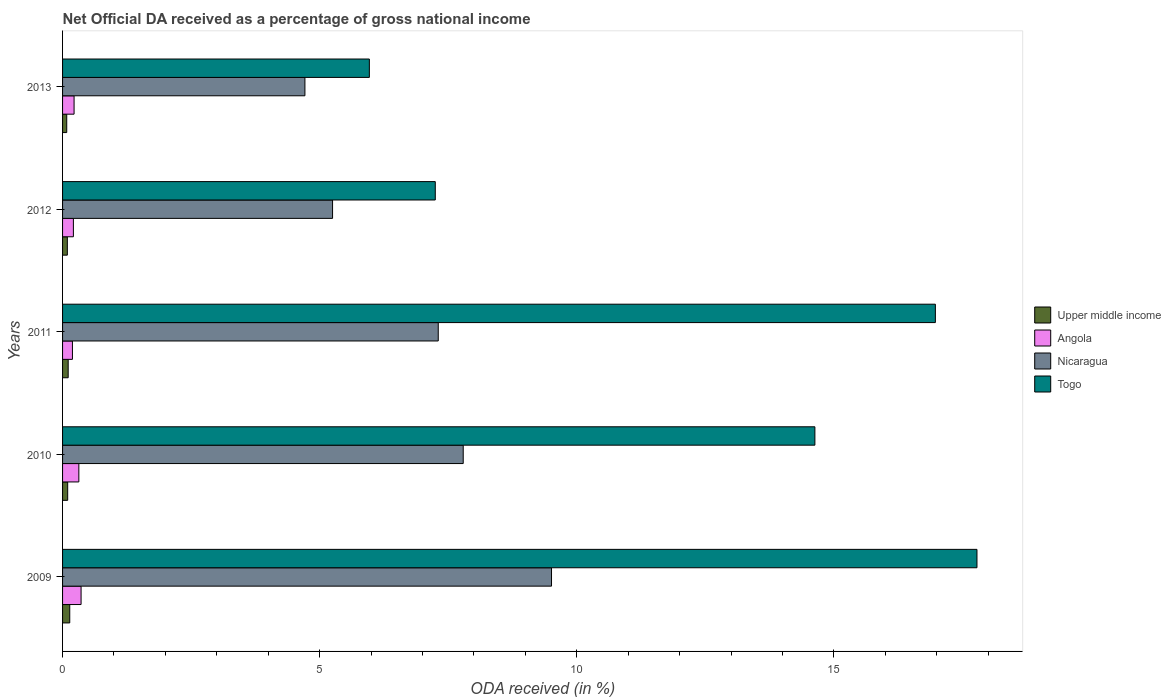How many different coloured bars are there?
Your answer should be compact. 4. Are the number of bars on each tick of the Y-axis equal?
Give a very brief answer. Yes. How many bars are there on the 1st tick from the top?
Your response must be concise. 4. What is the label of the 3rd group of bars from the top?
Offer a very short reply. 2011. In how many cases, is the number of bars for a given year not equal to the number of legend labels?
Your response must be concise. 0. What is the net official DA received in Togo in 2010?
Ensure brevity in your answer.  14.63. Across all years, what is the maximum net official DA received in Angola?
Keep it short and to the point. 0.36. Across all years, what is the minimum net official DA received in Togo?
Ensure brevity in your answer.  5.97. In which year was the net official DA received in Togo maximum?
Ensure brevity in your answer.  2009. What is the total net official DA received in Nicaragua in the graph?
Ensure brevity in your answer.  34.57. What is the difference between the net official DA received in Nicaragua in 2010 and that in 2013?
Your response must be concise. 3.08. What is the difference between the net official DA received in Togo in 2009 and the net official DA received in Nicaragua in 2012?
Provide a succinct answer. 12.53. What is the average net official DA received in Togo per year?
Your answer should be very brief. 12.52. In the year 2012, what is the difference between the net official DA received in Nicaragua and net official DA received in Togo?
Provide a succinct answer. -2. In how many years, is the net official DA received in Upper middle income greater than 13 %?
Your answer should be very brief. 0. What is the ratio of the net official DA received in Togo in 2009 to that in 2010?
Give a very brief answer. 1.22. Is the net official DA received in Upper middle income in 2010 less than that in 2013?
Your response must be concise. No. What is the difference between the highest and the second highest net official DA received in Upper middle income?
Make the answer very short. 0.03. What is the difference between the highest and the lowest net official DA received in Nicaragua?
Your answer should be compact. 4.8. In how many years, is the net official DA received in Nicaragua greater than the average net official DA received in Nicaragua taken over all years?
Ensure brevity in your answer.  3. Is the sum of the net official DA received in Togo in 2011 and 2012 greater than the maximum net official DA received in Upper middle income across all years?
Provide a short and direct response. Yes. What does the 3rd bar from the top in 2013 represents?
Ensure brevity in your answer.  Angola. What does the 3rd bar from the bottom in 2010 represents?
Offer a terse response. Nicaragua. Is it the case that in every year, the sum of the net official DA received in Nicaragua and net official DA received in Upper middle income is greater than the net official DA received in Angola?
Keep it short and to the point. Yes. How many years are there in the graph?
Your answer should be compact. 5. What is the difference between two consecutive major ticks on the X-axis?
Offer a very short reply. 5. Does the graph contain grids?
Offer a very short reply. No. What is the title of the graph?
Ensure brevity in your answer.  Net Official DA received as a percentage of gross national income. What is the label or title of the X-axis?
Make the answer very short. ODA received (in %). What is the label or title of the Y-axis?
Offer a very short reply. Years. What is the ODA received (in %) of Upper middle income in 2009?
Provide a succinct answer. 0.14. What is the ODA received (in %) in Angola in 2009?
Offer a very short reply. 0.36. What is the ODA received (in %) in Nicaragua in 2009?
Your response must be concise. 9.51. What is the ODA received (in %) of Togo in 2009?
Your answer should be very brief. 17.78. What is the ODA received (in %) of Upper middle income in 2010?
Make the answer very short. 0.1. What is the ODA received (in %) of Angola in 2010?
Your response must be concise. 0.32. What is the ODA received (in %) in Nicaragua in 2010?
Provide a short and direct response. 7.79. What is the ODA received (in %) of Togo in 2010?
Provide a succinct answer. 14.63. What is the ODA received (in %) of Upper middle income in 2011?
Offer a terse response. 0.11. What is the ODA received (in %) of Angola in 2011?
Your response must be concise. 0.19. What is the ODA received (in %) in Nicaragua in 2011?
Provide a short and direct response. 7.31. What is the ODA received (in %) in Togo in 2011?
Offer a very short reply. 16.97. What is the ODA received (in %) of Upper middle income in 2012?
Your answer should be very brief. 0.09. What is the ODA received (in %) in Angola in 2012?
Make the answer very short. 0.21. What is the ODA received (in %) in Nicaragua in 2012?
Ensure brevity in your answer.  5.25. What is the ODA received (in %) of Togo in 2012?
Your answer should be compact. 7.25. What is the ODA received (in %) of Upper middle income in 2013?
Your answer should be compact. 0.08. What is the ODA received (in %) in Angola in 2013?
Give a very brief answer. 0.22. What is the ODA received (in %) of Nicaragua in 2013?
Offer a terse response. 4.71. What is the ODA received (in %) in Togo in 2013?
Keep it short and to the point. 5.97. Across all years, what is the maximum ODA received (in %) in Upper middle income?
Your answer should be compact. 0.14. Across all years, what is the maximum ODA received (in %) of Angola?
Your response must be concise. 0.36. Across all years, what is the maximum ODA received (in %) of Nicaragua?
Make the answer very short. 9.51. Across all years, what is the maximum ODA received (in %) in Togo?
Offer a terse response. 17.78. Across all years, what is the minimum ODA received (in %) of Upper middle income?
Provide a short and direct response. 0.08. Across all years, what is the minimum ODA received (in %) of Angola?
Make the answer very short. 0.19. Across all years, what is the minimum ODA received (in %) of Nicaragua?
Offer a very short reply. 4.71. Across all years, what is the minimum ODA received (in %) in Togo?
Ensure brevity in your answer.  5.97. What is the total ODA received (in %) of Upper middle income in the graph?
Make the answer very short. 0.52. What is the total ODA received (in %) in Angola in the graph?
Your answer should be very brief. 1.3. What is the total ODA received (in %) in Nicaragua in the graph?
Offer a very short reply. 34.57. What is the total ODA received (in %) of Togo in the graph?
Provide a succinct answer. 62.6. What is the difference between the ODA received (in %) of Angola in 2009 and that in 2010?
Give a very brief answer. 0.04. What is the difference between the ODA received (in %) in Nicaragua in 2009 and that in 2010?
Keep it short and to the point. 1.72. What is the difference between the ODA received (in %) of Togo in 2009 and that in 2010?
Give a very brief answer. 3.15. What is the difference between the ODA received (in %) of Upper middle income in 2009 and that in 2011?
Provide a succinct answer. 0.03. What is the difference between the ODA received (in %) of Angola in 2009 and that in 2011?
Provide a succinct answer. 0.17. What is the difference between the ODA received (in %) of Nicaragua in 2009 and that in 2011?
Provide a succinct answer. 2.2. What is the difference between the ODA received (in %) of Togo in 2009 and that in 2011?
Give a very brief answer. 0.81. What is the difference between the ODA received (in %) in Upper middle income in 2009 and that in 2012?
Keep it short and to the point. 0.05. What is the difference between the ODA received (in %) in Angola in 2009 and that in 2012?
Offer a terse response. 0.15. What is the difference between the ODA received (in %) of Nicaragua in 2009 and that in 2012?
Your response must be concise. 4.26. What is the difference between the ODA received (in %) in Togo in 2009 and that in 2012?
Ensure brevity in your answer.  10.53. What is the difference between the ODA received (in %) of Upper middle income in 2009 and that in 2013?
Keep it short and to the point. 0.06. What is the difference between the ODA received (in %) of Angola in 2009 and that in 2013?
Provide a succinct answer. 0.14. What is the difference between the ODA received (in %) of Nicaragua in 2009 and that in 2013?
Make the answer very short. 4.8. What is the difference between the ODA received (in %) in Togo in 2009 and that in 2013?
Your answer should be very brief. 11.82. What is the difference between the ODA received (in %) of Upper middle income in 2010 and that in 2011?
Your answer should be very brief. -0.01. What is the difference between the ODA received (in %) of Angola in 2010 and that in 2011?
Provide a short and direct response. 0.12. What is the difference between the ODA received (in %) of Nicaragua in 2010 and that in 2011?
Your answer should be very brief. 0.49. What is the difference between the ODA received (in %) in Togo in 2010 and that in 2011?
Provide a succinct answer. -2.34. What is the difference between the ODA received (in %) in Upper middle income in 2010 and that in 2012?
Your answer should be very brief. 0.01. What is the difference between the ODA received (in %) of Angola in 2010 and that in 2012?
Your response must be concise. 0.11. What is the difference between the ODA received (in %) in Nicaragua in 2010 and that in 2012?
Offer a terse response. 2.54. What is the difference between the ODA received (in %) of Togo in 2010 and that in 2012?
Make the answer very short. 7.38. What is the difference between the ODA received (in %) in Upper middle income in 2010 and that in 2013?
Offer a terse response. 0.02. What is the difference between the ODA received (in %) of Angola in 2010 and that in 2013?
Offer a terse response. 0.09. What is the difference between the ODA received (in %) in Nicaragua in 2010 and that in 2013?
Your answer should be very brief. 3.08. What is the difference between the ODA received (in %) of Togo in 2010 and that in 2013?
Provide a succinct answer. 8.66. What is the difference between the ODA received (in %) in Upper middle income in 2011 and that in 2012?
Offer a terse response. 0.02. What is the difference between the ODA received (in %) in Angola in 2011 and that in 2012?
Your answer should be very brief. -0.02. What is the difference between the ODA received (in %) of Nicaragua in 2011 and that in 2012?
Give a very brief answer. 2.06. What is the difference between the ODA received (in %) of Togo in 2011 and that in 2012?
Make the answer very short. 9.73. What is the difference between the ODA received (in %) in Upper middle income in 2011 and that in 2013?
Offer a very short reply. 0.03. What is the difference between the ODA received (in %) of Angola in 2011 and that in 2013?
Give a very brief answer. -0.03. What is the difference between the ODA received (in %) in Nicaragua in 2011 and that in 2013?
Keep it short and to the point. 2.59. What is the difference between the ODA received (in %) in Togo in 2011 and that in 2013?
Your answer should be very brief. 11.01. What is the difference between the ODA received (in %) of Upper middle income in 2012 and that in 2013?
Give a very brief answer. 0.01. What is the difference between the ODA received (in %) in Angola in 2012 and that in 2013?
Offer a very short reply. -0.01. What is the difference between the ODA received (in %) in Nicaragua in 2012 and that in 2013?
Offer a terse response. 0.54. What is the difference between the ODA received (in %) in Togo in 2012 and that in 2013?
Your response must be concise. 1.28. What is the difference between the ODA received (in %) in Upper middle income in 2009 and the ODA received (in %) in Angola in 2010?
Keep it short and to the point. -0.18. What is the difference between the ODA received (in %) of Upper middle income in 2009 and the ODA received (in %) of Nicaragua in 2010?
Offer a very short reply. -7.65. What is the difference between the ODA received (in %) of Upper middle income in 2009 and the ODA received (in %) of Togo in 2010?
Provide a succinct answer. -14.49. What is the difference between the ODA received (in %) of Angola in 2009 and the ODA received (in %) of Nicaragua in 2010?
Your response must be concise. -7.43. What is the difference between the ODA received (in %) in Angola in 2009 and the ODA received (in %) in Togo in 2010?
Your answer should be very brief. -14.27. What is the difference between the ODA received (in %) in Nicaragua in 2009 and the ODA received (in %) in Togo in 2010?
Your answer should be very brief. -5.12. What is the difference between the ODA received (in %) of Upper middle income in 2009 and the ODA received (in %) of Angola in 2011?
Give a very brief answer. -0.05. What is the difference between the ODA received (in %) of Upper middle income in 2009 and the ODA received (in %) of Nicaragua in 2011?
Your response must be concise. -7.17. What is the difference between the ODA received (in %) in Upper middle income in 2009 and the ODA received (in %) in Togo in 2011?
Your response must be concise. -16.83. What is the difference between the ODA received (in %) of Angola in 2009 and the ODA received (in %) of Nicaragua in 2011?
Your answer should be very brief. -6.95. What is the difference between the ODA received (in %) in Angola in 2009 and the ODA received (in %) in Togo in 2011?
Make the answer very short. -16.61. What is the difference between the ODA received (in %) of Nicaragua in 2009 and the ODA received (in %) of Togo in 2011?
Keep it short and to the point. -7.46. What is the difference between the ODA received (in %) of Upper middle income in 2009 and the ODA received (in %) of Angola in 2012?
Keep it short and to the point. -0.07. What is the difference between the ODA received (in %) of Upper middle income in 2009 and the ODA received (in %) of Nicaragua in 2012?
Provide a short and direct response. -5.11. What is the difference between the ODA received (in %) of Upper middle income in 2009 and the ODA received (in %) of Togo in 2012?
Your answer should be compact. -7.11. What is the difference between the ODA received (in %) in Angola in 2009 and the ODA received (in %) in Nicaragua in 2012?
Provide a short and direct response. -4.89. What is the difference between the ODA received (in %) of Angola in 2009 and the ODA received (in %) of Togo in 2012?
Offer a terse response. -6.89. What is the difference between the ODA received (in %) of Nicaragua in 2009 and the ODA received (in %) of Togo in 2012?
Your answer should be very brief. 2.26. What is the difference between the ODA received (in %) in Upper middle income in 2009 and the ODA received (in %) in Angola in 2013?
Keep it short and to the point. -0.08. What is the difference between the ODA received (in %) of Upper middle income in 2009 and the ODA received (in %) of Nicaragua in 2013?
Your answer should be compact. -4.57. What is the difference between the ODA received (in %) in Upper middle income in 2009 and the ODA received (in %) in Togo in 2013?
Offer a terse response. -5.83. What is the difference between the ODA received (in %) in Angola in 2009 and the ODA received (in %) in Nicaragua in 2013?
Offer a terse response. -4.35. What is the difference between the ODA received (in %) of Angola in 2009 and the ODA received (in %) of Togo in 2013?
Make the answer very short. -5.61. What is the difference between the ODA received (in %) of Nicaragua in 2009 and the ODA received (in %) of Togo in 2013?
Provide a succinct answer. 3.54. What is the difference between the ODA received (in %) in Upper middle income in 2010 and the ODA received (in %) in Angola in 2011?
Provide a succinct answer. -0.09. What is the difference between the ODA received (in %) in Upper middle income in 2010 and the ODA received (in %) in Nicaragua in 2011?
Ensure brevity in your answer.  -7.21. What is the difference between the ODA received (in %) of Upper middle income in 2010 and the ODA received (in %) of Togo in 2011?
Ensure brevity in your answer.  -16.87. What is the difference between the ODA received (in %) in Angola in 2010 and the ODA received (in %) in Nicaragua in 2011?
Keep it short and to the point. -6.99. What is the difference between the ODA received (in %) of Angola in 2010 and the ODA received (in %) of Togo in 2011?
Give a very brief answer. -16.66. What is the difference between the ODA received (in %) of Nicaragua in 2010 and the ODA received (in %) of Togo in 2011?
Make the answer very short. -9.18. What is the difference between the ODA received (in %) of Upper middle income in 2010 and the ODA received (in %) of Angola in 2012?
Make the answer very short. -0.11. What is the difference between the ODA received (in %) in Upper middle income in 2010 and the ODA received (in %) in Nicaragua in 2012?
Your answer should be compact. -5.15. What is the difference between the ODA received (in %) in Upper middle income in 2010 and the ODA received (in %) in Togo in 2012?
Your answer should be compact. -7.15. What is the difference between the ODA received (in %) of Angola in 2010 and the ODA received (in %) of Nicaragua in 2012?
Offer a very short reply. -4.93. What is the difference between the ODA received (in %) in Angola in 2010 and the ODA received (in %) in Togo in 2012?
Give a very brief answer. -6.93. What is the difference between the ODA received (in %) in Nicaragua in 2010 and the ODA received (in %) in Togo in 2012?
Your answer should be compact. 0.54. What is the difference between the ODA received (in %) of Upper middle income in 2010 and the ODA received (in %) of Angola in 2013?
Keep it short and to the point. -0.12. What is the difference between the ODA received (in %) of Upper middle income in 2010 and the ODA received (in %) of Nicaragua in 2013?
Your answer should be compact. -4.61. What is the difference between the ODA received (in %) of Upper middle income in 2010 and the ODA received (in %) of Togo in 2013?
Your answer should be compact. -5.87. What is the difference between the ODA received (in %) in Angola in 2010 and the ODA received (in %) in Nicaragua in 2013?
Your response must be concise. -4.4. What is the difference between the ODA received (in %) of Angola in 2010 and the ODA received (in %) of Togo in 2013?
Make the answer very short. -5.65. What is the difference between the ODA received (in %) in Nicaragua in 2010 and the ODA received (in %) in Togo in 2013?
Give a very brief answer. 1.83. What is the difference between the ODA received (in %) of Upper middle income in 2011 and the ODA received (in %) of Angola in 2012?
Offer a very short reply. -0.1. What is the difference between the ODA received (in %) in Upper middle income in 2011 and the ODA received (in %) in Nicaragua in 2012?
Give a very brief answer. -5.14. What is the difference between the ODA received (in %) of Upper middle income in 2011 and the ODA received (in %) of Togo in 2012?
Offer a terse response. -7.14. What is the difference between the ODA received (in %) of Angola in 2011 and the ODA received (in %) of Nicaragua in 2012?
Provide a short and direct response. -5.06. What is the difference between the ODA received (in %) of Angola in 2011 and the ODA received (in %) of Togo in 2012?
Your response must be concise. -7.06. What is the difference between the ODA received (in %) in Nicaragua in 2011 and the ODA received (in %) in Togo in 2012?
Keep it short and to the point. 0.06. What is the difference between the ODA received (in %) of Upper middle income in 2011 and the ODA received (in %) of Angola in 2013?
Give a very brief answer. -0.11. What is the difference between the ODA received (in %) of Upper middle income in 2011 and the ODA received (in %) of Nicaragua in 2013?
Your answer should be very brief. -4.6. What is the difference between the ODA received (in %) of Upper middle income in 2011 and the ODA received (in %) of Togo in 2013?
Your response must be concise. -5.86. What is the difference between the ODA received (in %) of Angola in 2011 and the ODA received (in %) of Nicaragua in 2013?
Your response must be concise. -4.52. What is the difference between the ODA received (in %) of Angola in 2011 and the ODA received (in %) of Togo in 2013?
Your answer should be very brief. -5.77. What is the difference between the ODA received (in %) in Nicaragua in 2011 and the ODA received (in %) in Togo in 2013?
Provide a succinct answer. 1.34. What is the difference between the ODA received (in %) of Upper middle income in 2012 and the ODA received (in %) of Angola in 2013?
Your answer should be very brief. -0.13. What is the difference between the ODA received (in %) in Upper middle income in 2012 and the ODA received (in %) in Nicaragua in 2013?
Your answer should be very brief. -4.62. What is the difference between the ODA received (in %) of Upper middle income in 2012 and the ODA received (in %) of Togo in 2013?
Offer a very short reply. -5.87. What is the difference between the ODA received (in %) of Angola in 2012 and the ODA received (in %) of Nicaragua in 2013?
Your answer should be compact. -4.5. What is the difference between the ODA received (in %) of Angola in 2012 and the ODA received (in %) of Togo in 2013?
Give a very brief answer. -5.76. What is the difference between the ODA received (in %) of Nicaragua in 2012 and the ODA received (in %) of Togo in 2013?
Your response must be concise. -0.72. What is the average ODA received (in %) of Upper middle income per year?
Give a very brief answer. 0.1. What is the average ODA received (in %) of Angola per year?
Give a very brief answer. 0.26. What is the average ODA received (in %) of Nicaragua per year?
Your answer should be compact. 6.91. What is the average ODA received (in %) in Togo per year?
Keep it short and to the point. 12.52. In the year 2009, what is the difference between the ODA received (in %) of Upper middle income and ODA received (in %) of Angola?
Keep it short and to the point. -0.22. In the year 2009, what is the difference between the ODA received (in %) of Upper middle income and ODA received (in %) of Nicaragua?
Ensure brevity in your answer.  -9.37. In the year 2009, what is the difference between the ODA received (in %) of Upper middle income and ODA received (in %) of Togo?
Give a very brief answer. -17.64. In the year 2009, what is the difference between the ODA received (in %) in Angola and ODA received (in %) in Nicaragua?
Your response must be concise. -9.15. In the year 2009, what is the difference between the ODA received (in %) of Angola and ODA received (in %) of Togo?
Give a very brief answer. -17.42. In the year 2009, what is the difference between the ODA received (in %) in Nicaragua and ODA received (in %) in Togo?
Provide a succinct answer. -8.27. In the year 2010, what is the difference between the ODA received (in %) in Upper middle income and ODA received (in %) in Angola?
Offer a very short reply. -0.22. In the year 2010, what is the difference between the ODA received (in %) of Upper middle income and ODA received (in %) of Nicaragua?
Ensure brevity in your answer.  -7.69. In the year 2010, what is the difference between the ODA received (in %) of Upper middle income and ODA received (in %) of Togo?
Keep it short and to the point. -14.53. In the year 2010, what is the difference between the ODA received (in %) in Angola and ODA received (in %) in Nicaragua?
Make the answer very short. -7.48. In the year 2010, what is the difference between the ODA received (in %) in Angola and ODA received (in %) in Togo?
Provide a succinct answer. -14.31. In the year 2010, what is the difference between the ODA received (in %) in Nicaragua and ODA received (in %) in Togo?
Provide a short and direct response. -6.84. In the year 2011, what is the difference between the ODA received (in %) in Upper middle income and ODA received (in %) in Angola?
Provide a short and direct response. -0.08. In the year 2011, what is the difference between the ODA received (in %) of Upper middle income and ODA received (in %) of Nicaragua?
Your response must be concise. -7.2. In the year 2011, what is the difference between the ODA received (in %) in Upper middle income and ODA received (in %) in Togo?
Your answer should be very brief. -16.86. In the year 2011, what is the difference between the ODA received (in %) of Angola and ODA received (in %) of Nicaragua?
Provide a succinct answer. -7.11. In the year 2011, what is the difference between the ODA received (in %) of Angola and ODA received (in %) of Togo?
Your answer should be very brief. -16.78. In the year 2011, what is the difference between the ODA received (in %) in Nicaragua and ODA received (in %) in Togo?
Provide a succinct answer. -9.67. In the year 2012, what is the difference between the ODA received (in %) in Upper middle income and ODA received (in %) in Angola?
Your answer should be very brief. -0.12. In the year 2012, what is the difference between the ODA received (in %) of Upper middle income and ODA received (in %) of Nicaragua?
Ensure brevity in your answer.  -5.16. In the year 2012, what is the difference between the ODA received (in %) of Upper middle income and ODA received (in %) of Togo?
Ensure brevity in your answer.  -7.16. In the year 2012, what is the difference between the ODA received (in %) of Angola and ODA received (in %) of Nicaragua?
Offer a terse response. -5.04. In the year 2012, what is the difference between the ODA received (in %) of Angola and ODA received (in %) of Togo?
Provide a succinct answer. -7.04. In the year 2012, what is the difference between the ODA received (in %) in Nicaragua and ODA received (in %) in Togo?
Your response must be concise. -2. In the year 2013, what is the difference between the ODA received (in %) in Upper middle income and ODA received (in %) in Angola?
Keep it short and to the point. -0.14. In the year 2013, what is the difference between the ODA received (in %) of Upper middle income and ODA received (in %) of Nicaragua?
Your response must be concise. -4.63. In the year 2013, what is the difference between the ODA received (in %) in Upper middle income and ODA received (in %) in Togo?
Your response must be concise. -5.89. In the year 2013, what is the difference between the ODA received (in %) of Angola and ODA received (in %) of Nicaragua?
Offer a terse response. -4.49. In the year 2013, what is the difference between the ODA received (in %) of Angola and ODA received (in %) of Togo?
Your response must be concise. -5.74. In the year 2013, what is the difference between the ODA received (in %) in Nicaragua and ODA received (in %) in Togo?
Provide a short and direct response. -1.25. What is the ratio of the ODA received (in %) of Upper middle income in 2009 to that in 2010?
Provide a succinct answer. 1.4. What is the ratio of the ODA received (in %) in Angola in 2009 to that in 2010?
Offer a very short reply. 1.14. What is the ratio of the ODA received (in %) in Nicaragua in 2009 to that in 2010?
Provide a succinct answer. 1.22. What is the ratio of the ODA received (in %) in Togo in 2009 to that in 2010?
Your response must be concise. 1.22. What is the ratio of the ODA received (in %) of Upper middle income in 2009 to that in 2011?
Offer a very short reply. 1.28. What is the ratio of the ODA received (in %) in Angola in 2009 to that in 2011?
Offer a terse response. 1.87. What is the ratio of the ODA received (in %) in Nicaragua in 2009 to that in 2011?
Offer a very short reply. 1.3. What is the ratio of the ODA received (in %) of Togo in 2009 to that in 2011?
Make the answer very short. 1.05. What is the ratio of the ODA received (in %) in Upper middle income in 2009 to that in 2012?
Your answer should be very brief. 1.51. What is the ratio of the ODA received (in %) in Angola in 2009 to that in 2012?
Make the answer very short. 1.71. What is the ratio of the ODA received (in %) of Nicaragua in 2009 to that in 2012?
Your answer should be compact. 1.81. What is the ratio of the ODA received (in %) of Togo in 2009 to that in 2012?
Keep it short and to the point. 2.45. What is the ratio of the ODA received (in %) of Upper middle income in 2009 to that in 2013?
Offer a terse response. 1.72. What is the ratio of the ODA received (in %) in Angola in 2009 to that in 2013?
Offer a very short reply. 1.61. What is the ratio of the ODA received (in %) of Nicaragua in 2009 to that in 2013?
Your response must be concise. 2.02. What is the ratio of the ODA received (in %) of Togo in 2009 to that in 2013?
Provide a succinct answer. 2.98. What is the ratio of the ODA received (in %) in Upper middle income in 2010 to that in 2011?
Provide a short and direct response. 0.91. What is the ratio of the ODA received (in %) in Angola in 2010 to that in 2011?
Your answer should be very brief. 1.65. What is the ratio of the ODA received (in %) of Nicaragua in 2010 to that in 2011?
Provide a short and direct response. 1.07. What is the ratio of the ODA received (in %) of Togo in 2010 to that in 2011?
Offer a very short reply. 0.86. What is the ratio of the ODA received (in %) of Upper middle income in 2010 to that in 2012?
Give a very brief answer. 1.07. What is the ratio of the ODA received (in %) in Angola in 2010 to that in 2012?
Provide a succinct answer. 1.5. What is the ratio of the ODA received (in %) of Nicaragua in 2010 to that in 2012?
Offer a very short reply. 1.48. What is the ratio of the ODA received (in %) in Togo in 2010 to that in 2012?
Your response must be concise. 2.02. What is the ratio of the ODA received (in %) of Upper middle income in 2010 to that in 2013?
Make the answer very short. 1.23. What is the ratio of the ODA received (in %) in Angola in 2010 to that in 2013?
Provide a short and direct response. 1.41. What is the ratio of the ODA received (in %) in Nicaragua in 2010 to that in 2013?
Your answer should be very brief. 1.65. What is the ratio of the ODA received (in %) of Togo in 2010 to that in 2013?
Provide a succinct answer. 2.45. What is the ratio of the ODA received (in %) of Upper middle income in 2011 to that in 2012?
Make the answer very short. 1.18. What is the ratio of the ODA received (in %) in Angola in 2011 to that in 2012?
Provide a succinct answer. 0.91. What is the ratio of the ODA received (in %) of Nicaragua in 2011 to that in 2012?
Your answer should be compact. 1.39. What is the ratio of the ODA received (in %) of Togo in 2011 to that in 2012?
Offer a very short reply. 2.34. What is the ratio of the ODA received (in %) of Upper middle income in 2011 to that in 2013?
Your answer should be compact. 1.35. What is the ratio of the ODA received (in %) of Angola in 2011 to that in 2013?
Offer a very short reply. 0.86. What is the ratio of the ODA received (in %) in Nicaragua in 2011 to that in 2013?
Offer a very short reply. 1.55. What is the ratio of the ODA received (in %) in Togo in 2011 to that in 2013?
Provide a short and direct response. 2.84. What is the ratio of the ODA received (in %) of Upper middle income in 2012 to that in 2013?
Offer a very short reply. 1.14. What is the ratio of the ODA received (in %) in Angola in 2012 to that in 2013?
Offer a terse response. 0.94. What is the ratio of the ODA received (in %) in Nicaragua in 2012 to that in 2013?
Provide a short and direct response. 1.11. What is the ratio of the ODA received (in %) of Togo in 2012 to that in 2013?
Give a very brief answer. 1.21. What is the difference between the highest and the second highest ODA received (in %) in Upper middle income?
Provide a short and direct response. 0.03. What is the difference between the highest and the second highest ODA received (in %) in Angola?
Give a very brief answer. 0.04. What is the difference between the highest and the second highest ODA received (in %) in Nicaragua?
Your answer should be compact. 1.72. What is the difference between the highest and the second highest ODA received (in %) in Togo?
Make the answer very short. 0.81. What is the difference between the highest and the lowest ODA received (in %) in Upper middle income?
Make the answer very short. 0.06. What is the difference between the highest and the lowest ODA received (in %) in Angola?
Give a very brief answer. 0.17. What is the difference between the highest and the lowest ODA received (in %) of Nicaragua?
Provide a short and direct response. 4.8. What is the difference between the highest and the lowest ODA received (in %) in Togo?
Your answer should be compact. 11.82. 